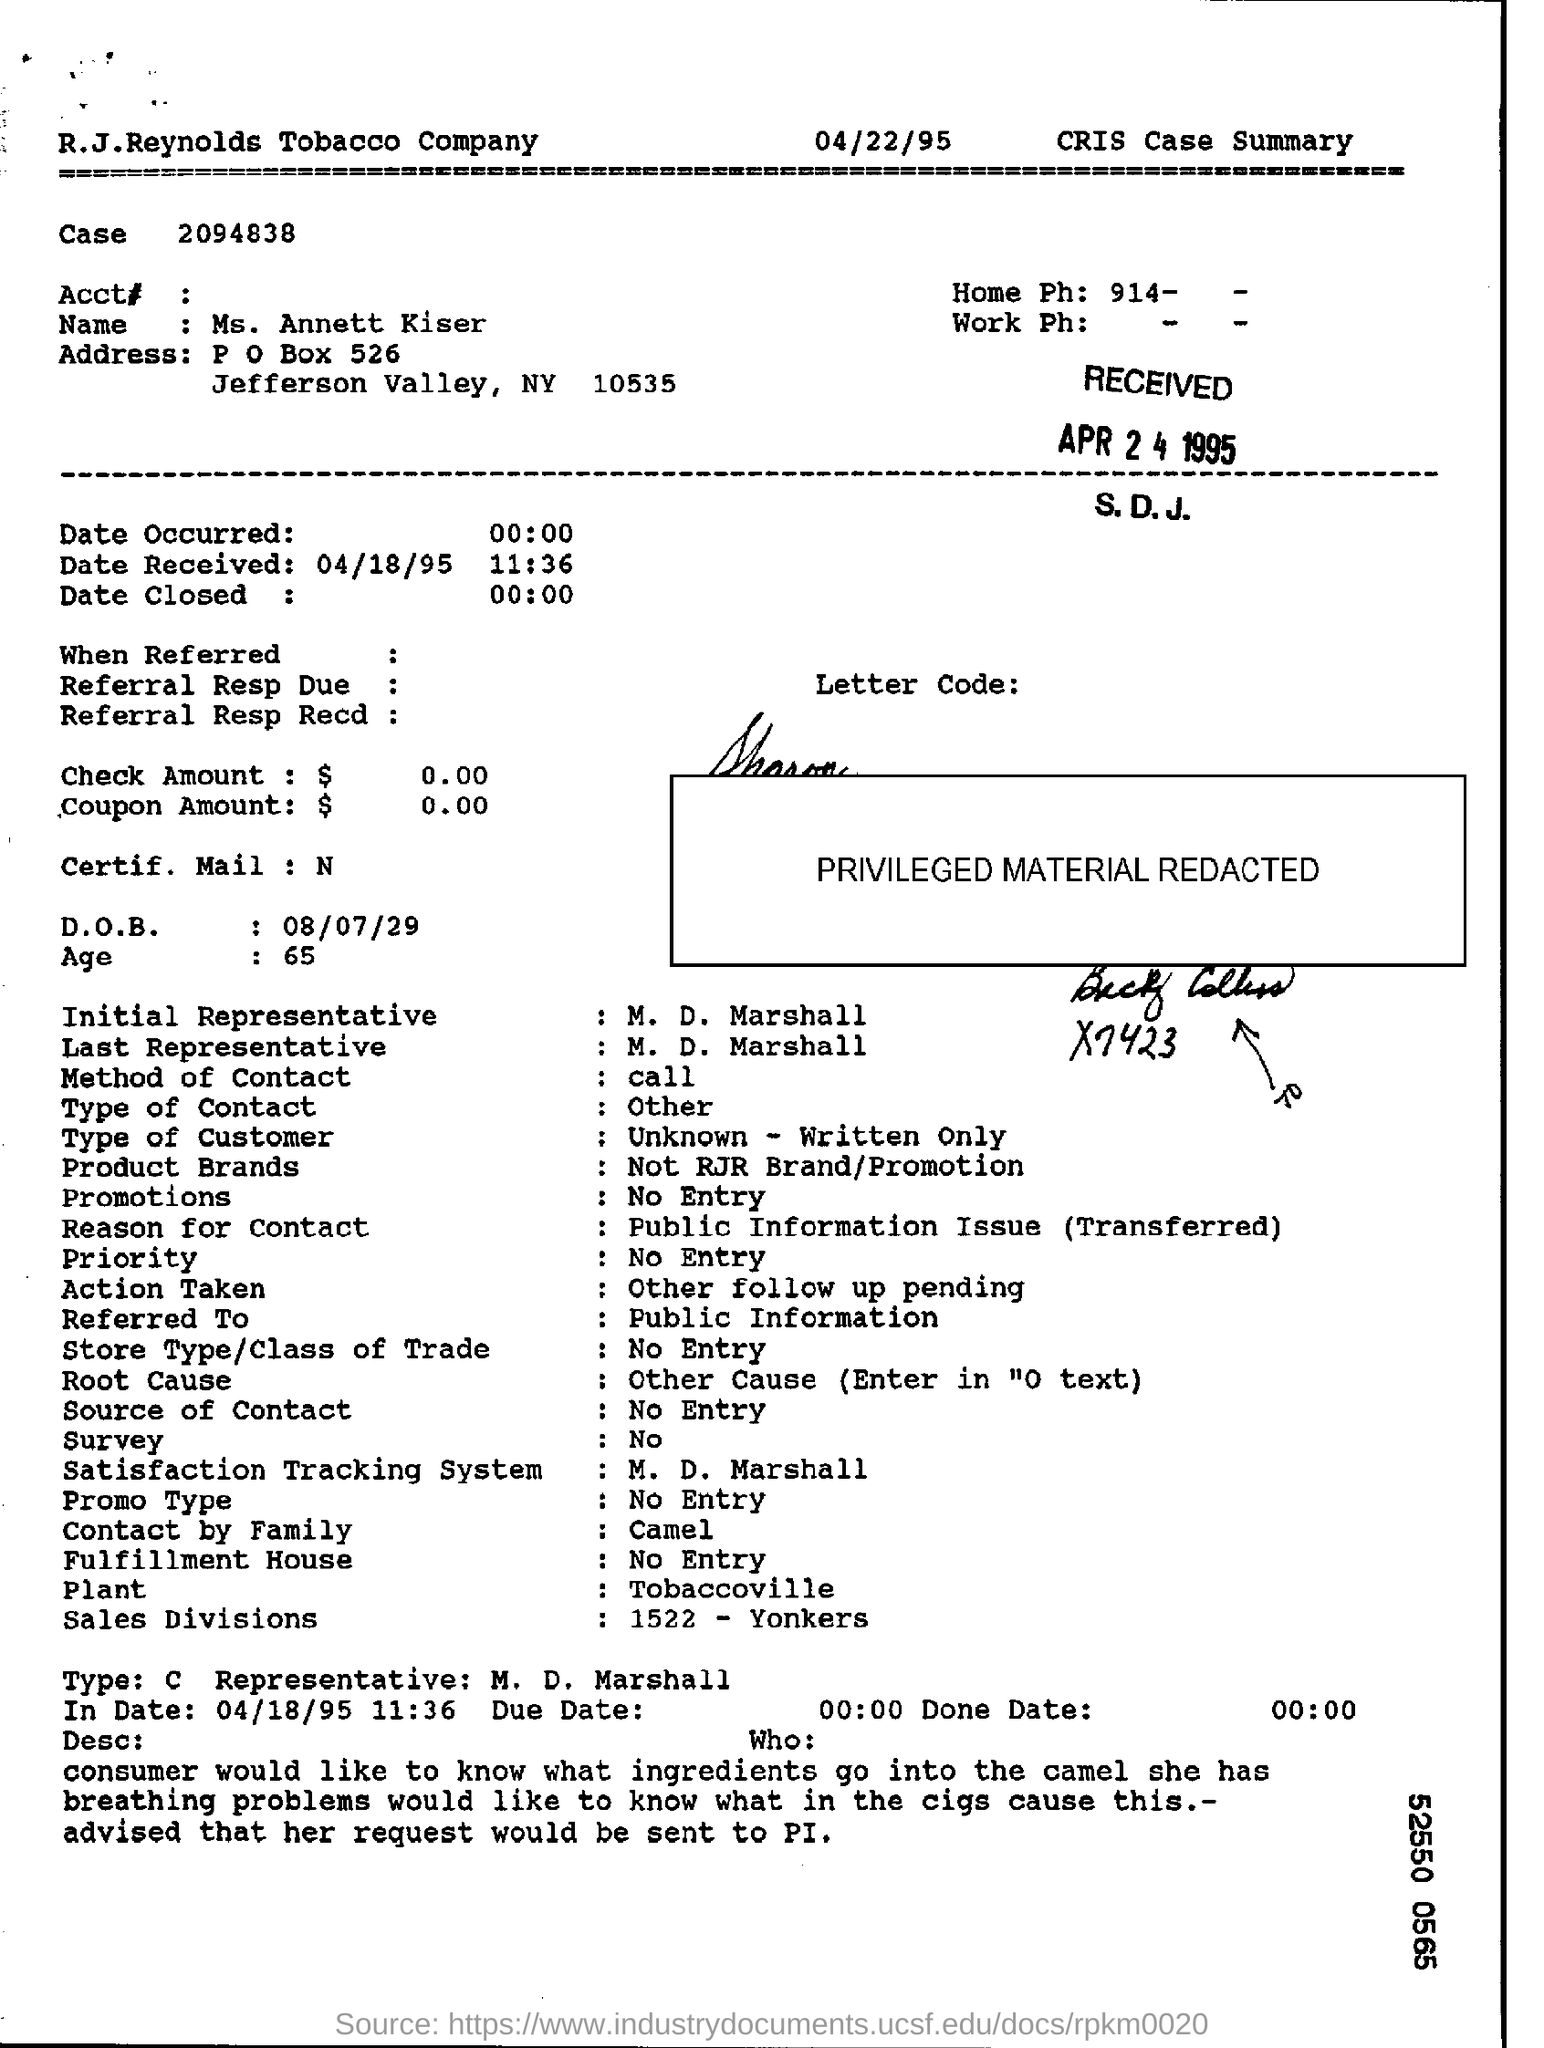List a handful of essential elements in this visual. The name of the person in the CRIS case summary is Ms. Annett Kiser. The date of birth in the CRIS case summary is August 7, 1929. 